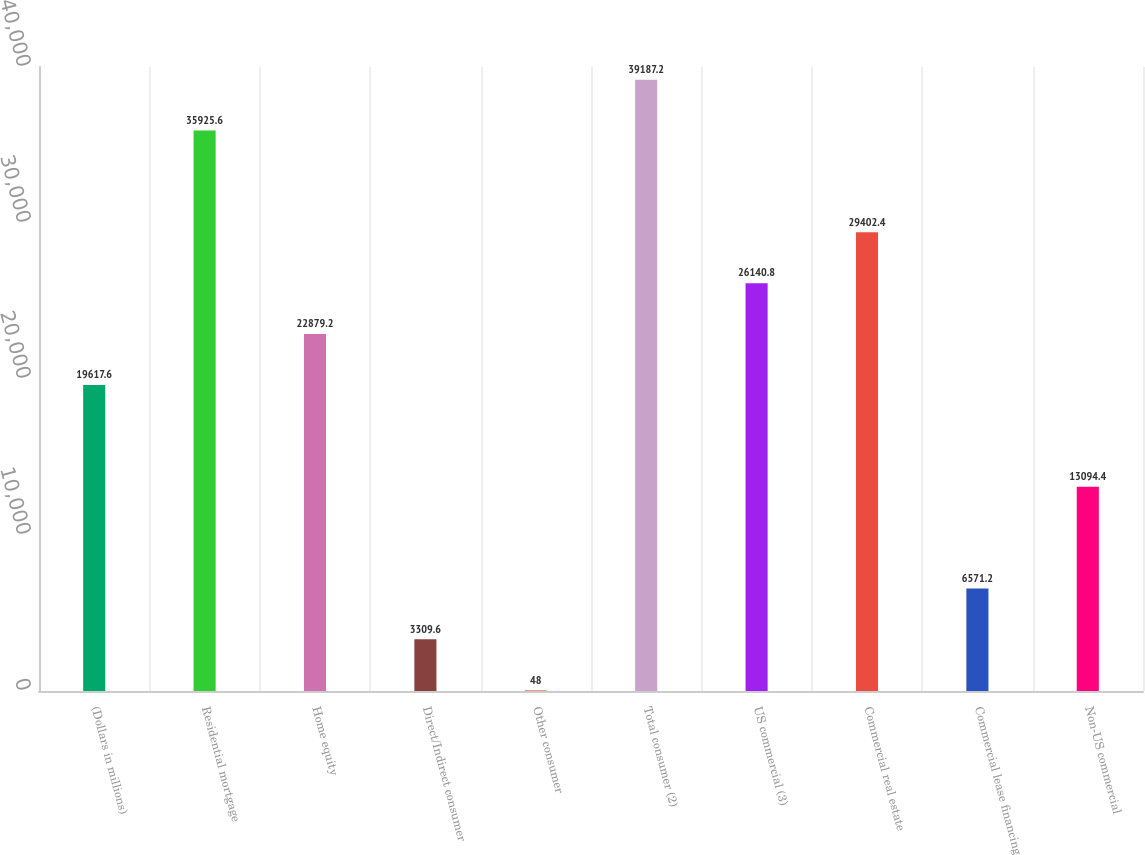Convert chart to OTSL. <chart><loc_0><loc_0><loc_500><loc_500><bar_chart><fcel>(Dollars in millions)<fcel>Residential mortgage<fcel>Home equity<fcel>Direct/Indirect consumer<fcel>Other consumer<fcel>Total consumer (2)<fcel>US commercial (3)<fcel>Commercial real estate<fcel>Commercial lease financing<fcel>Non-US commercial<nl><fcel>19617.6<fcel>35925.6<fcel>22879.2<fcel>3309.6<fcel>48<fcel>39187.2<fcel>26140.8<fcel>29402.4<fcel>6571.2<fcel>13094.4<nl></chart> 